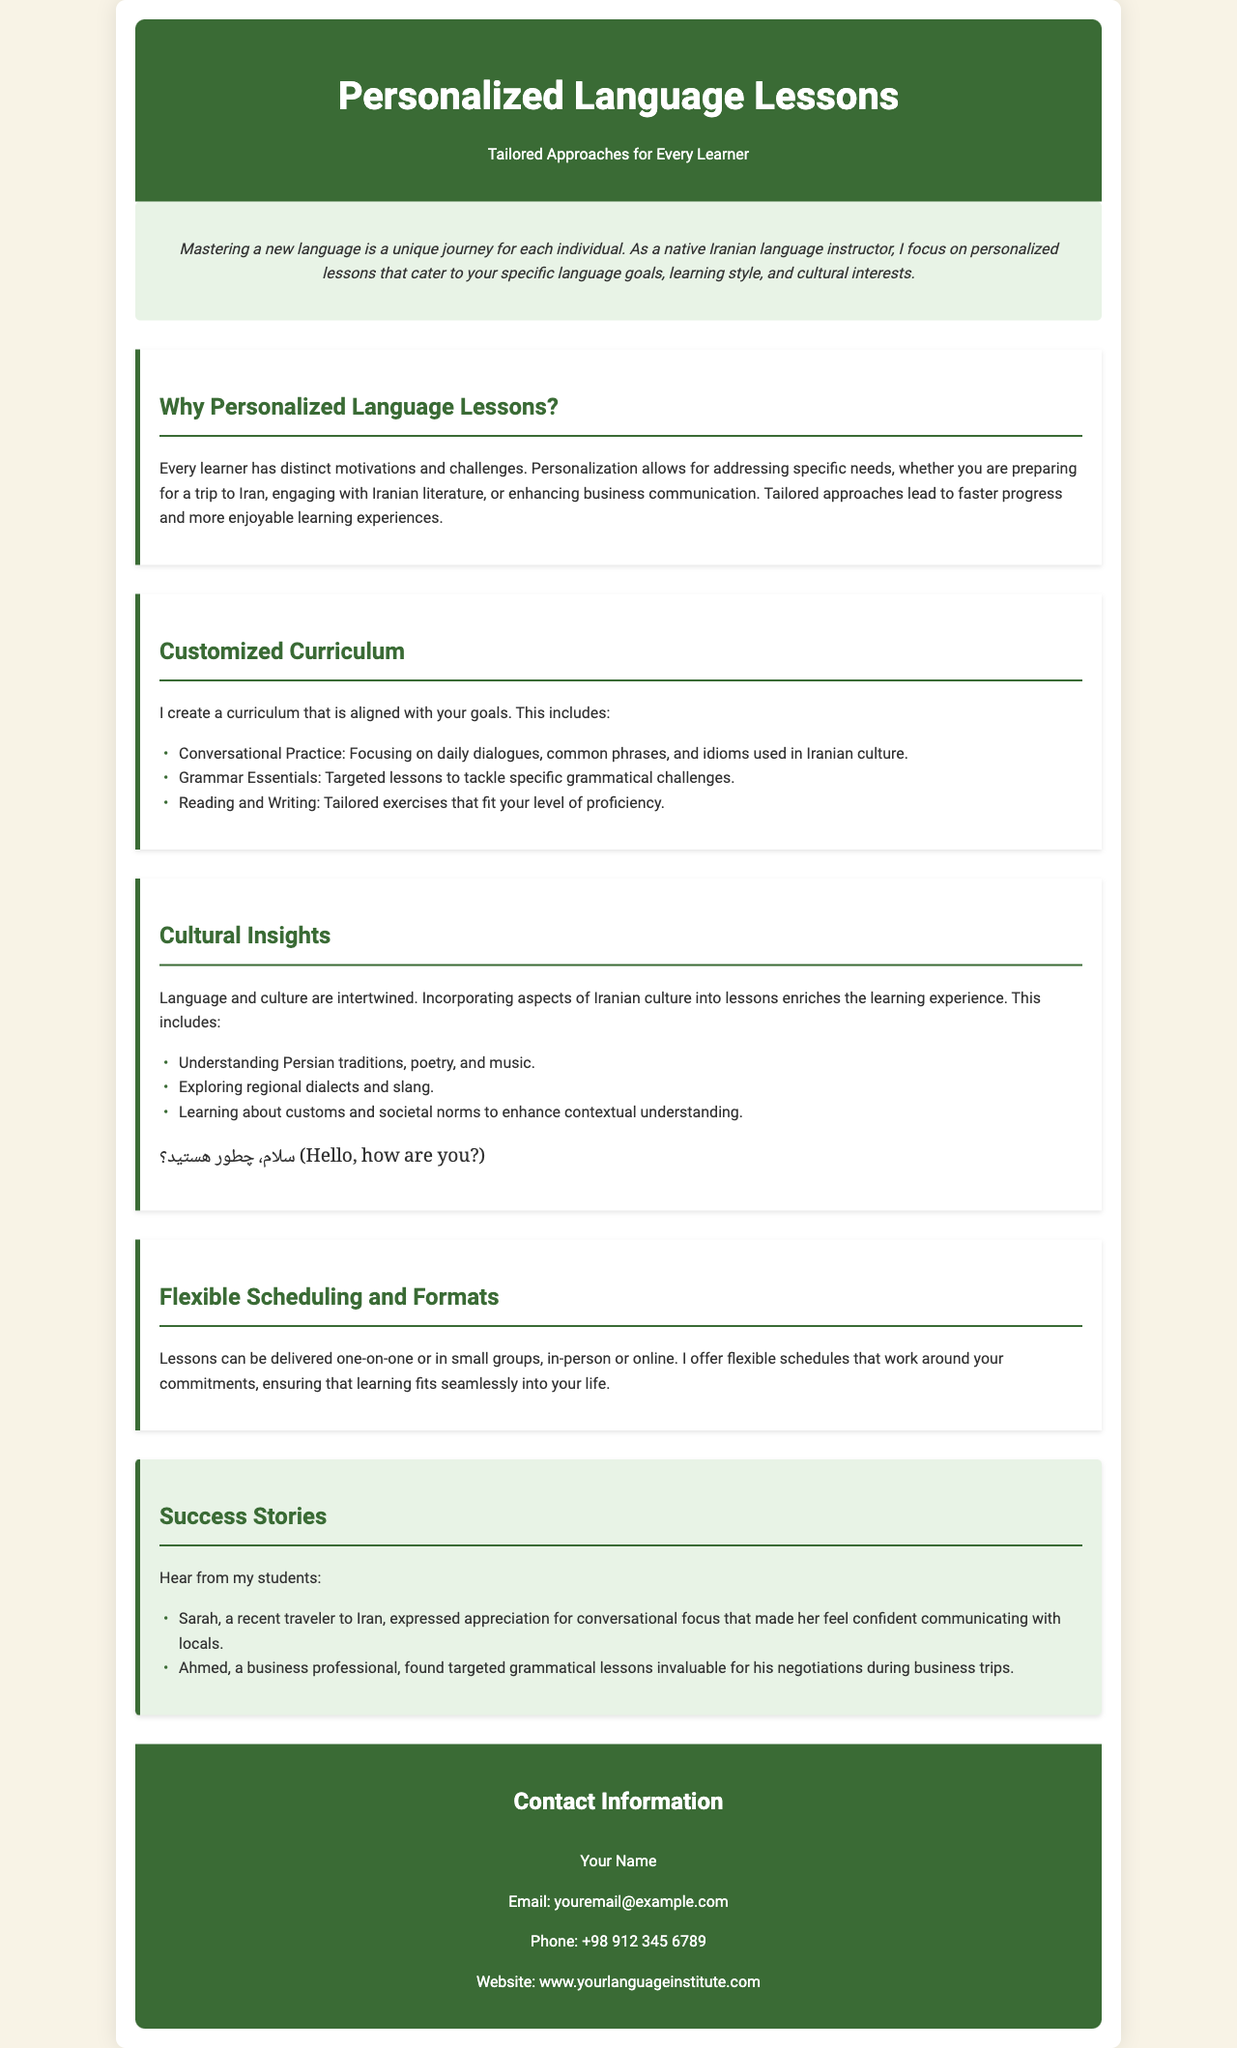What is the main focus of the lessons? The main focus of the lessons is on personalized approaches that cater to specific language goals, learning styles, and cultural interests.
Answer: Personalized approaches Who is the instructor? The instructor is a native Iranian language instructor.
Answer: Native Iranian language instructor What are the three components of the customized curriculum? The three components are conversational practice, grammar essentials, and reading and writing.
Answer: Conversational practice, grammar essentials, reading and writing What is included in the cultural insights section? The cultural insights section includes understanding Persian traditions, exploring regional dialects, and learning about customs.
Answer: Understanding Persian traditions, exploring regional dialects, learning about customs How can lessons be delivered? Lessons can be delivered one-on-one or in small groups, in-person or online.
Answer: One-on-one, small groups, in-person, online Who expressed appreciation for conversational focus? Sarah expressed appreciation for conversational focus.
Answer: Sarah What is the email address provided for contact? The email address provided for contact is youremail@example.com.
Answer: youremail@example.com How many success stories are mentioned? Two success stories are mentioned in the document.
Answer: Two 